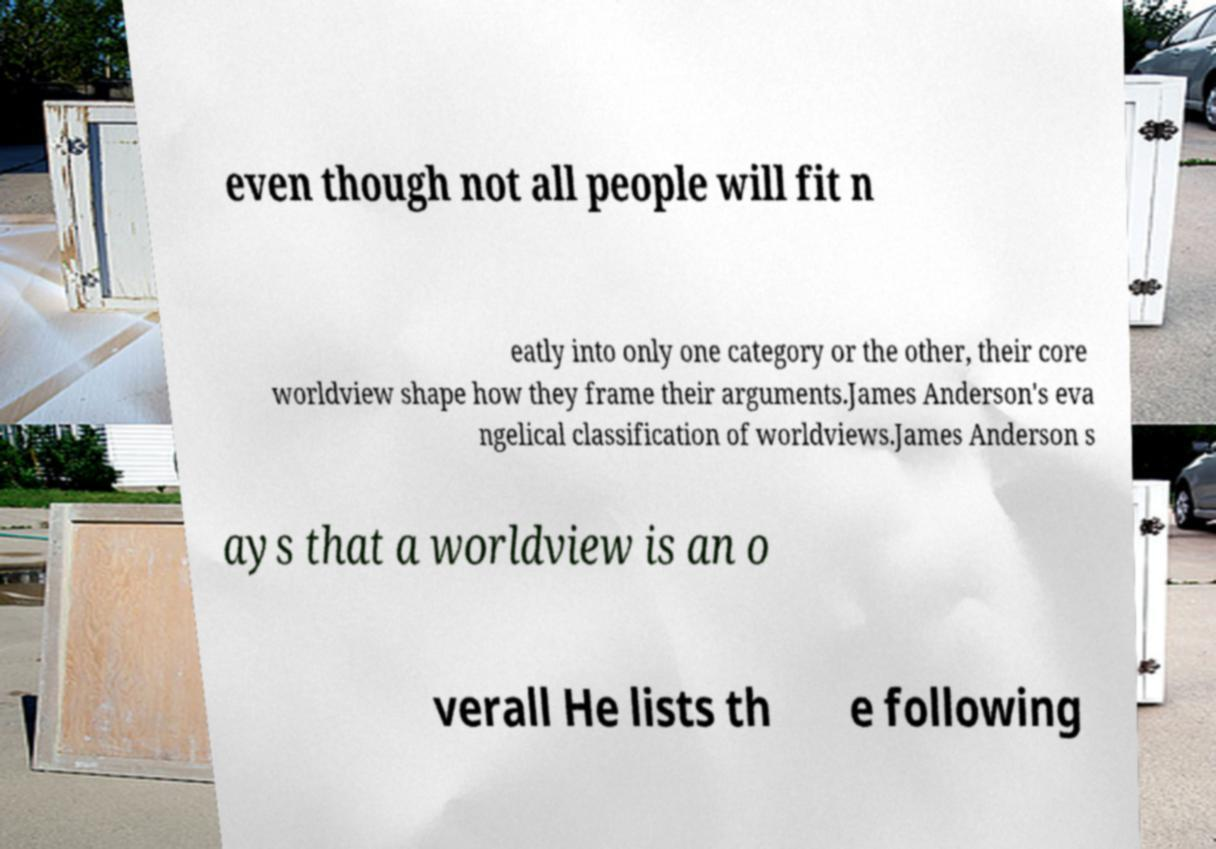Could you assist in decoding the text presented in this image and type it out clearly? even though not all people will fit n eatly into only one category or the other, their core worldview shape how they frame their arguments.James Anderson's eva ngelical classification of worldviews.James Anderson s ays that a worldview is an o verall He lists th e following 